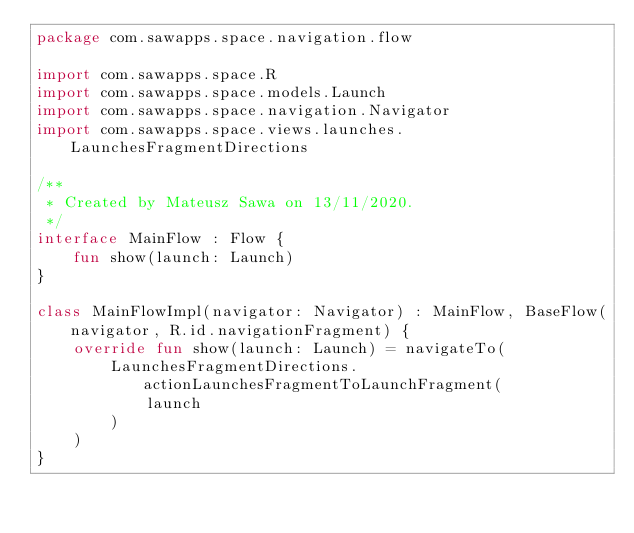<code> <loc_0><loc_0><loc_500><loc_500><_Kotlin_>package com.sawapps.space.navigation.flow

import com.sawapps.space.R
import com.sawapps.space.models.Launch
import com.sawapps.space.navigation.Navigator
import com.sawapps.space.views.launches.LaunchesFragmentDirections

/**
 * Created by Mateusz Sawa on 13/11/2020.
 */
interface MainFlow : Flow {
    fun show(launch: Launch)
}

class MainFlowImpl(navigator: Navigator) : MainFlow, BaseFlow(navigator, R.id.navigationFragment) {
    override fun show(launch: Launch) = navigateTo(
        LaunchesFragmentDirections.actionLaunchesFragmentToLaunchFragment(
            launch
        )
    )
}</code> 